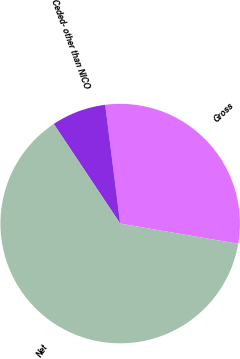<chart> <loc_0><loc_0><loc_500><loc_500><pie_chart><fcel>Gross<fcel>Ceded- other than NICO<fcel>Net<nl><fcel>29.7%<fcel>7.36%<fcel>62.94%<nl></chart> 